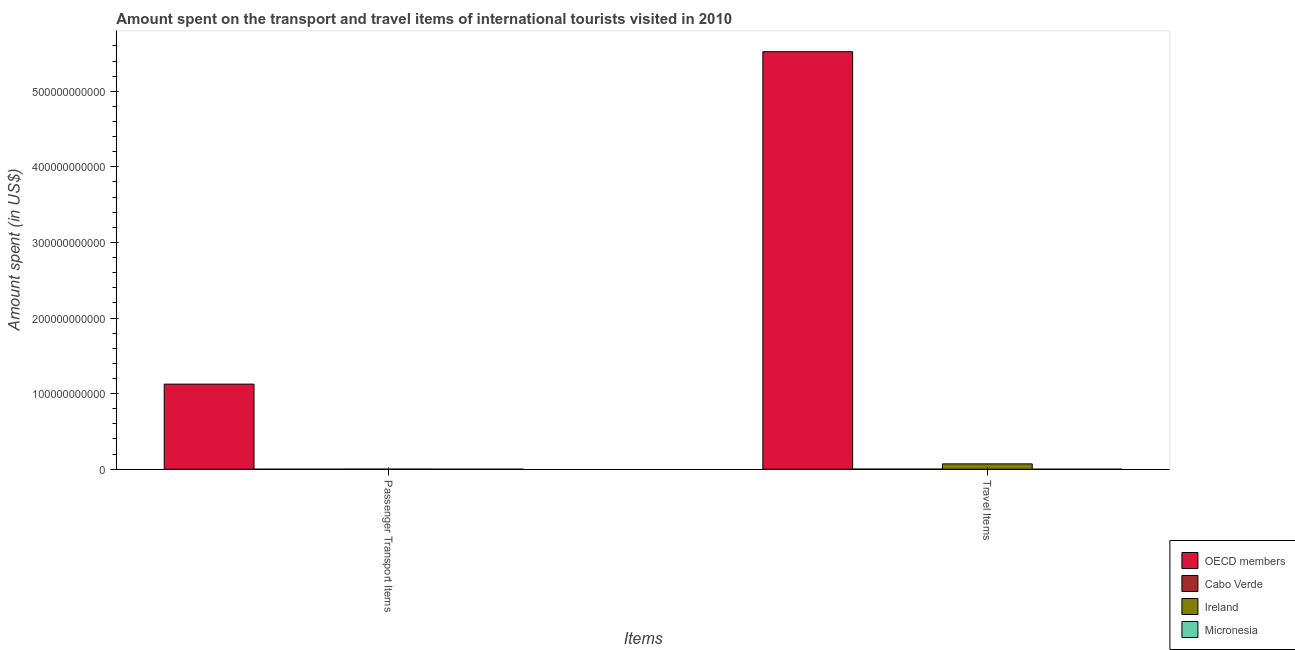How many different coloured bars are there?
Provide a short and direct response. 4. How many groups of bars are there?
Offer a very short reply. 2. Are the number of bars per tick equal to the number of legend labels?
Provide a succinct answer. Yes. Are the number of bars on each tick of the X-axis equal?
Your answer should be very brief. Yes. What is the label of the 2nd group of bars from the left?
Your answer should be very brief. Travel Items. What is the amount spent on passenger transport items in Micronesia?
Offer a terse response. 1.60e+07. Across all countries, what is the maximum amount spent in travel items?
Your answer should be compact. 5.52e+11. Across all countries, what is the minimum amount spent on passenger transport items?
Provide a succinct answer. 9.00e+06. In which country was the amount spent in travel items minimum?
Make the answer very short. Micronesia. What is the total amount spent on passenger transport items in the graph?
Your answer should be compact. 1.13e+11. What is the difference between the amount spent on passenger transport items in Micronesia and that in Ireland?
Your response must be concise. -9.10e+07. What is the difference between the amount spent on passenger transport items in OECD members and the amount spent in travel items in Micronesia?
Make the answer very short. 1.13e+11. What is the average amount spent on passenger transport items per country?
Make the answer very short. 2.82e+1. What is the difference between the amount spent on passenger transport items and amount spent in travel items in Cabo Verde?
Keep it short and to the point. -1.20e+08. What is the ratio of the amount spent on passenger transport items in Micronesia to that in Ireland?
Offer a terse response. 0.15. Is the amount spent on passenger transport items in Cabo Verde less than that in Ireland?
Provide a short and direct response. Yes. What does the 2nd bar from the left in Passenger Transport Items represents?
Give a very brief answer. Cabo Verde. What does the 1st bar from the right in Travel Items represents?
Give a very brief answer. Micronesia. Are all the bars in the graph horizontal?
Provide a short and direct response. No. What is the difference between two consecutive major ticks on the Y-axis?
Offer a very short reply. 1.00e+11. Are the values on the major ticks of Y-axis written in scientific E-notation?
Provide a short and direct response. No. How many legend labels are there?
Make the answer very short. 4. How are the legend labels stacked?
Provide a succinct answer. Vertical. What is the title of the graph?
Make the answer very short. Amount spent on the transport and travel items of international tourists visited in 2010. What is the label or title of the X-axis?
Ensure brevity in your answer.  Items. What is the label or title of the Y-axis?
Your answer should be very brief. Amount spent (in US$). What is the Amount spent (in US$) in OECD members in Passenger Transport Items?
Your answer should be compact. 1.13e+11. What is the Amount spent (in US$) in Cabo Verde in Passenger Transport Items?
Give a very brief answer. 9.00e+06. What is the Amount spent (in US$) of Ireland in Passenger Transport Items?
Your answer should be compact. 1.07e+08. What is the Amount spent (in US$) in Micronesia in Passenger Transport Items?
Provide a short and direct response. 1.60e+07. What is the Amount spent (in US$) of OECD members in Travel Items?
Offer a very short reply. 5.52e+11. What is the Amount spent (in US$) of Cabo Verde in Travel Items?
Your response must be concise. 1.29e+08. What is the Amount spent (in US$) of Ireland in Travel Items?
Your response must be concise. 7.07e+09. What is the Amount spent (in US$) of Micronesia in Travel Items?
Your response must be concise. 1.20e+07. Across all Items, what is the maximum Amount spent (in US$) of OECD members?
Your answer should be very brief. 5.52e+11. Across all Items, what is the maximum Amount spent (in US$) of Cabo Verde?
Your answer should be very brief. 1.29e+08. Across all Items, what is the maximum Amount spent (in US$) of Ireland?
Offer a very short reply. 7.07e+09. Across all Items, what is the maximum Amount spent (in US$) in Micronesia?
Your answer should be compact. 1.60e+07. Across all Items, what is the minimum Amount spent (in US$) in OECD members?
Provide a short and direct response. 1.13e+11. Across all Items, what is the minimum Amount spent (in US$) in Cabo Verde?
Keep it short and to the point. 9.00e+06. Across all Items, what is the minimum Amount spent (in US$) in Ireland?
Provide a short and direct response. 1.07e+08. What is the total Amount spent (in US$) of OECD members in the graph?
Your answer should be compact. 6.65e+11. What is the total Amount spent (in US$) of Cabo Verde in the graph?
Offer a very short reply. 1.38e+08. What is the total Amount spent (in US$) in Ireland in the graph?
Your answer should be very brief. 7.18e+09. What is the total Amount spent (in US$) in Micronesia in the graph?
Provide a short and direct response. 2.80e+07. What is the difference between the Amount spent (in US$) in OECD members in Passenger Transport Items and that in Travel Items?
Give a very brief answer. -4.40e+11. What is the difference between the Amount spent (in US$) in Cabo Verde in Passenger Transport Items and that in Travel Items?
Your answer should be very brief. -1.20e+08. What is the difference between the Amount spent (in US$) in Ireland in Passenger Transport Items and that in Travel Items?
Your response must be concise. -6.96e+09. What is the difference between the Amount spent (in US$) of OECD members in Passenger Transport Items and the Amount spent (in US$) of Cabo Verde in Travel Items?
Keep it short and to the point. 1.12e+11. What is the difference between the Amount spent (in US$) in OECD members in Passenger Transport Items and the Amount spent (in US$) in Ireland in Travel Items?
Offer a very short reply. 1.06e+11. What is the difference between the Amount spent (in US$) of OECD members in Passenger Transport Items and the Amount spent (in US$) of Micronesia in Travel Items?
Make the answer very short. 1.13e+11. What is the difference between the Amount spent (in US$) of Cabo Verde in Passenger Transport Items and the Amount spent (in US$) of Ireland in Travel Items?
Your answer should be very brief. -7.06e+09. What is the difference between the Amount spent (in US$) of Cabo Verde in Passenger Transport Items and the Amount spent (in US$) of Micronesia in Travel Items?
Provide a succinct answer. -3.00e+06. What is the difference between the Amount spent (in US$) of Ireland in Passenger Transport Items and the Amount spent (in US$) of Micronesia in Travel Items?
Keep it short and to the point. 9.50e+07. What is the average Amount spent (in US$) of OECD members per Items?
Your answer should be very brief. 3.32e+11. What is the average Amount spent (in US$) of Cabo Verde per Items?
Keep it short and to the point. 6.90e+07. What is the average Amount spent (in US$) of Ireland per Items?
Offer a very short reply. 3.59e+09. What is the average Amount spent (in US$) in Micronesia per Items?
Keep it short and to the point. 1.40e+07. What is the difference between the Amount spent (in US$) of OECD members and Amount spent (in US$) of Cabo Verde in Passenger Transport Items?
Offer a very short reply. 1.13e+11. What is the difference between the Amount spent (in US$) of OECD members and Amount spent (in US$) of Ireland in Passenger Transport Items?
Provide a short and direct response. 1.12e+11. What is the difference between the Amount spent (in US$) in OECD members and Amount spent (in US$) in Micronesia in Passenger Transport Items?
Provide a short and direct response. 1.13e+11. What is the difference between the Amount spent (in US$) in Cabo Verde and Amount spent (in US$) in Ireland in Passenger Transport Items?
Offer a very short reply. -9.80e+07. What is the difference between the Amount spent (in US$) in Cabo Verde and Amount spent (in US$) in Micronesia in Passenger Transport Items?
Make the answer very short. -7.00e+06. What is the difference between the Amount spent (in US$) in Ireland and Amount spent (in US$) in Micronesia in Passenger Transport Items?
Provide a succinct answer. 9.10e+07. What is the difference between the Amount spent (in US$) in OECD members and Amount spent (in US$) in Cabo Verde in Travel Items?
Your answer should be very brief. 5.52e+11. What is the difference between the Amount spent (in US$) in OECD members and Amount spent (in US$) in Ireland in Travel Items?
Your answer should be very brief. 5.45e+11. What is the difference between the Amount spent (in US$) in OECD members and Amount spent (in US$) in Micronesia in Travel Items?
Ensure brevity in your answer.  5.52e+11. What is the difference between the Amount spent (in US$) in Cabo Verde and Amount spent (in US$) in Ireland in Travel Items?
Provide a succinct answer. -6.94e+09. What is the difference between the Amount spent (in US$) of Cabo Verde and Amount spent (in US$) of Micronesia in Travel Items?
Your response must be concise. 1.17e+08. What is the difference between the Amount spent (in US$) of Ireland and Amount spent (in US$) of Micronesia in Travel Items?
Make the answer very short. 7.06e+09. What is the ratio of the Amount spent (in US$) of OECD members in Passenger Transport Items to that in Travel Items?
Offer a very short reply. 0.2. What is the ratio of the Amount spent (in US$) of Cabo Verde in Passenger Transport Items to that in Travel Items?
Provide a succinct answer. 0.07. What is the ratio of the Amount spent (in US$) in Ireland in Passenger Transport Items to that in Travel Items?
Offer a terse response. 0.02. What is the difference between the highest and the second highest Amount spent (in US$) in OECD members?
Give a very brief answer. 4.40e+11. What is the difference between the highest and the second highest Amount spent (in US$) in Cabo Verde?
Your answer should be compact. 1.20e+08. What is the difference between the highest and the second highest Amount spent (in US$) in Ireland?
Ensure brevity in your answer.  6.96e+09. What is the difference between the highest and the second highest Amount spent (in US$) of Micronesia?
Offer a terse response. 4.00e+06. What is the difference between the highest and the lowest Amount spent (in US$) of OECD members?
Your answer should be compact. 4.40e+11. What is the difference between the highest and the lowest Amount spent (in US$) in Cabo Verde?
Give a very brief answer. 1.20e+08. What is the difference between the highest and the lowest Amount spent (in US$) of Ireland?
Give a very brief answer. 6.96e+09. What is the difference between the highest and the lowest Amount spent (in US$) of Micronesia?
Offer a terse response. 4.00e+06. 